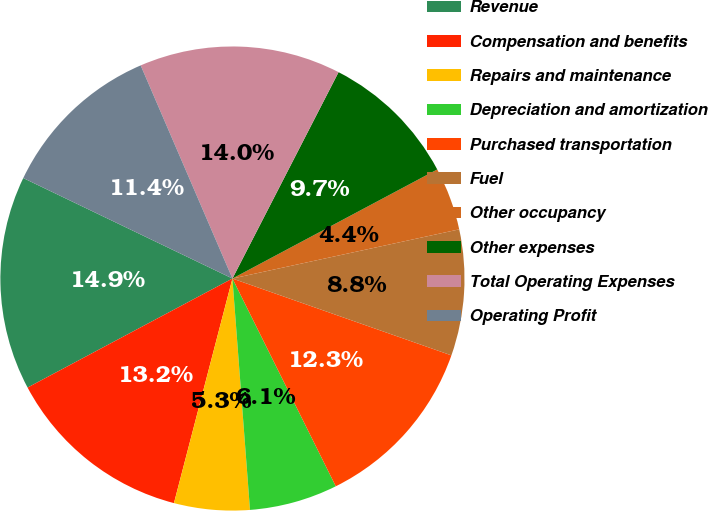Convert chart. <chart><loc_0><loc_0><loc_500><loc_500><pie_chart><fcel>Revenue<fcel>Compensation and benefits<fcel>Repairs and maintenance<fcel>Depreciation and amortization<fcel>Purchased transportation<fcel>Fuel<fcel>Other occupancy<fcel>Other expenses<fcel>Total Operating Expenses<fcel>Operating Profit<nl><fcel>14.91%<fcel>13.16%<fcel>5.26%<fcel>6.14%<fcel>12.28%<fcel>8.77%<fcel>4.39%<fcel>9.65%<fcel>14.03%<fcel>11.4%<nl></chart> 